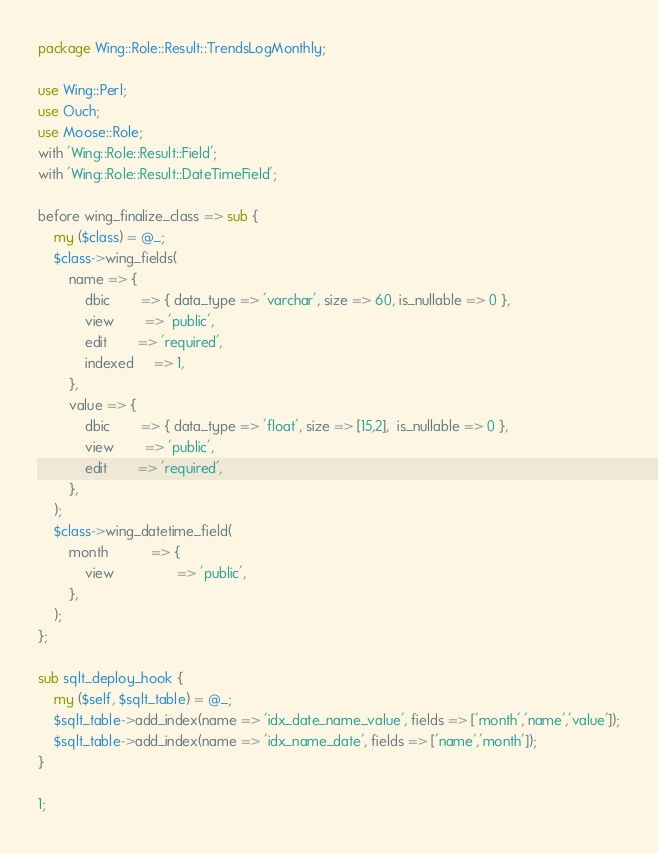<code> <loc_0><loc_0><loc_500><loc_500><_Perl_>package Wing::Role::Result::TrendsLogMonthly;

use Wing::Perl;
use Ouch;
use Moose::Role;
with 'Wing::Role::Result::Field';
with 'Wing::Role::Result::DateTimeField';

before wing_finalize_class => sub {
    my ($class) = @_;
    $class->wing_fields(
        name => {
            dbic 		=> { data_type => 'varchar', size => 60, is_nullable => 0 },
            view		=> 'public',
            edit		=> 'required',
            indexed     => 1,
        },
        value => {
            dbic 		=> { data_type => 'float', size => [15,2],  is_nullable => 0 },
            view		=> 'public',
            edit		=> 'required',
        },
    );
    $class->wing_datetime_field(
        month           => {
            view                => 'public',
        },
    );
};

sub sqlt_deploy_hook {
    my ($self, $sqlt_table) = @_;
    $sqlt_table->add_index(name => 'idx_date_name_value', fields => ['month','name','value']);
    $sqlt_table->add_index(name => 'idx_name_date', fields => ['name','month']);
}

1;
</code> 